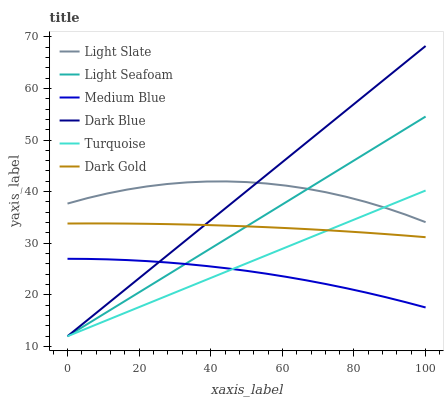Does Medium Blue have the minimum area under the curve?
Answer yes or no. Yes. Does Dark Blue have the maximum area under the curve?
Answer yes or no. Yes. Does Dark Gold have the minimum area under the curve?
Answer yes or no. No. Does Dark Gold have the maximum area under the curve?
Answer yes or no. No. Is Dark Blue the smoothest?
Answer yes or no. Yes. Is Light Slate the roughest?
Answer yes or no. Yes. Is Dark Gold the smoothest?
Answer yes or no. No. Is Dark Gold the roughest?
Answer yes or no. No. Does Turquoise have the lowest value?
Answer yes or no. Yes. Does Dark Gold have the lowest value?
Answer yes or no. No. Does Dark Blue have the highest value?
Answer yes or no. Yes. Does Dark Gold have the highest value?
Answer yes or no. No. Is Medium Blue less than Dark Gold?
Answer yes or no. Yes. Is Light Slate greater than Medium Blue?
Answer yes or no. Yes. Does Medium Blue intersect Dark Blue?
Answer yes or no. Yes. Is Medium Blue less than Dark Blue?
Answer yes or no. No. Is Medium Blue greater than Dark Blue?
Answer yes or no. No. Does Medium Blue intersect Dark Gold?
Answer yes or no. No. 